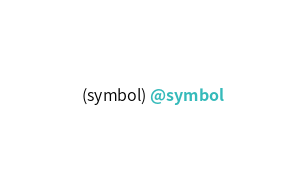Convert code to text. <code><loc_0><loc_0><loc_500><loc_500><_Scheme_>(symbol) @symbol
</code> 